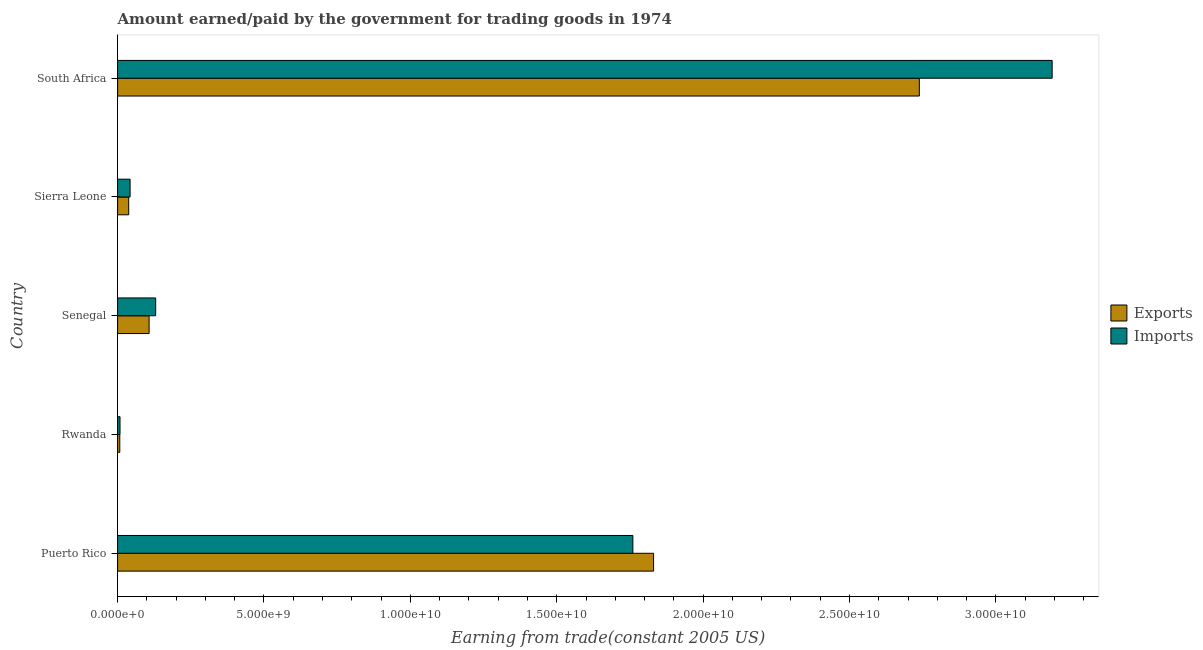Are the number of bars on each tick of the Y-axis equal?
Give a very brief answer. Yes. How many bars are there on the 5th tick from the top?
Provide a short and direct response. 2. How many bars are there on the 1st tick from the bottom?
Offer a very short reply. 2. What is the label of the 2nd group of bars from the top?
Give a very brief answer. Sierra Leone. In how many cases, is the number of bars for a given country not equal to the number of legend labels?
Give a very brief answer. 0. What is the amount paid for imports in Senegal?
Your answer should be very brief. 1.30e+09. Across all countries, what is the maximum amount earned from exports?
Ensure brevity in your answer.  2.74e+1. Across all countries, what is the minimum amount paid for imports?
Offer a very short reply. 8.25e+07. In which country was the amount earned from exports maximum?
Make the answer very short. South Africa. In which country was the amount earned from exports minimum?
Make the answer very short. Rwanda. What is the total amount paid for imports in the graph?
Offer a terse response. 5.13e+1. What is the difference between the amount paid for imports in Puerto Rico and that in Senegal?
Offer a terse response. 1.63e+1. What is the difference between the amount earned from exports in Sierra Leone and the amount paid for imports in South Africa?
Offer a terse response. -3.15e+1. What is the average amount earned from exports per country?
Your answer should be compact. 9.44e+09. What is the difference between the amount paid for imports and amount earned from exports in Rwanda?
Provide a succinct answer. 8.28e+06. What is the ratio of the amount paid for imports in Rwanda to that in Sierra Leone?
Offer a terse response. 0.19. What is the difference between the highest and the second highest amount earned from exports?
Provide a succinct answer. 9.08e+09. What is the difference between the highest and the lowest amount paid for imports?
Offer a very short reply. 3.18e+1. Is the sum of the amount paid for imports in Rwanda and Senegal greater than the maximum amount earned from exports across all countries?
Provide a succinct answer. No. What does the 1st bar from the top in Senegal represents?
Give a very brief answer. Imports. What does the 2nd bar from the bottom in Puerto Rico represents?
Provide a succinct answer. Imports. Are all the bars in the graph horizontal?
Your response must be concise. Yes. Does the graph contain any zero values?
Provide a short and direct response. No. How many legend labels are there?
Your answer should be compact. 2. What is the title of the graph?
Give a very brief answer. Amount earned/paid by the government for trading goods in 1974. What is the label or title of the X-axis?
Ensure brevity in your answer.  Earning from trade(constant 2005 US). What is the label or title of the Y-axis?
Your answer should be very brief. Country. What is the Earning from trade(constant 2005 US) in Exports in Puerto Rico?
Provide a succinct answer. 1.83e+1. What is the Earning from trade(constant 2005 US) of Imports in Puerto Rico?
Offer a terse response. 1.76e+1. What is the Earning from trade(constant 2005 US) in Exports in Rwanda?
Your response must be concise. 7.42e+07. What is the Earning from trade(constant 2005 US) in Imports in Rwanda?
Make the answer very short. 8.25e+07. What is the Earning from trade(constant 2005 US) of Exports in Senegal?
Keep it short and to the point. 1.08e+09. What is the Earning from trade(constant 2005 US) of Imports in Senegal?
Keep it short and to the point. 1.30e+09. What is the Earning from trade(constant 2005 US) in Exports in Sierra Leone?
Your answer should be compact. 3.79e+08. What is the Earning from trade(constant 2005 US) of Imports in Sierra Leone?
Offer a terse response. 4.26e+08. What is the Earning from trade(constant 2005 US) in Exports in South Africa?
Make the answer very short. 2.74e+1. What is the Earning from trade(constant 2005 US) of Imports in South Africa?
Your answer should be very brief. 3.19e+1. Across all countries, what is the maximum Earning from trade(constant 2005 US) in Exports?
Your answer should be very brief. 2.74e+1. Across all countries, what is the maximum Earning from trade(constant 2005 US) of Imports?
Ensure brevity in your answer.  3.19e+1. Across all countries, what is the minimum Earning from trade(constant 2005 US) in Exports?
Provide a succinct answer. 7.42e+07. Across all countries, what is the minimum Earning from trade(constant 2005 US) of Imports?
Offer a terse response. 8.25e+07. What is the total Earning from trade(constant 2005 US) in Exports in the graph?
Your answer should be compact. 4.72e+1. What is the total Earning from trade(constant 2005 US) in Imports in the graph?
Provide a short and direct response. 5.13e+1. What is the difference between the Earning from trade(constant 2005 US) in Exports in Puerto Rico and that in Rwanda?
Keep it short and to the point. 1.82e+1. What is the difference between the Earning from trade(constant 2005 US) in Imports in Puerto Rico and that in Rwanda?
Keep it short and to the point. 1.75e+1. What is the difference between the Earning from trade(constant 2005 US) of Exports in Puerto Rico and that in Senegal?
Keep it short and to the point. 1.72e+1. What is the difference between the Earning from trade(constant 2005 US) of Imports in Puerto Rico and that in Senegal?
Your answer should be very brief. 1.63e+1. What is the difference between the Earning from trade(constant 2005 US) of Exports in Puerto Rico and that in Sierra Leone?
Your answer should be very brief. 1.79e+1. What is the difference between the Earning from trade(constant 2005 US) of Imports in Puerto Rico and that in Sierra Leone?
Keep it short and to the point. 1.72e+1. What is the difference between the Earning from trade(constant 2005 US) in Exports in Puerto Rico and that in South Africa?
Provide a short and direct response. -9.08e+09. What is the difference between the Earning from trade(constant 2005 US) in Imports in Puerto Rico and that in South Africa?
Offer a terse response. -1.43e+1. What is the difference between the Earning from trade(constant 2005 US) in Exports in Rwanda and that in Senegal?
Provide a short and direct response. -1.00e+09. What is the difference between the Earning from trade(constant 2005 US) of Imports in Rwanda and that in Senegal?
Provide a succinct answer. -1.22e+09. What is the difference between the Earning from trade(constant 2005 US) in Exports in Rwanda and that in Sierra Leone?
Your answer should be compact. -3.05e+08. What is the difference between the Earning from trade(constant 2005 US) in Imports in Rwanda and that in Sierra Leone?
Ensure brevity in your answer.  -3.44e+08. What is the difference between the Earning from trade(constant 2005 US) in Exports in Rwanda and that in South Africa?
Your response must be concise. -2.73e+1. What is the difference between the Earning from trade(constant 2005 US) in Imports in Rwanda and that in South Africa?
Your answer should be compact. -3.18e+1. What is the difference between the Earning from trade(constant 2005 US) in Exports in Senegal and that in Sierra Leone?
Your response must be concise. 6.97e+08. What is the difference between the Earning from trade(constant 2005 US) of Imports in Senegal and that in Sierra Leone?
Ensure brevity in your answer.  8.74e+08. What is the difference between the Earning from trade(constant 2005 US) of Exports in Senegal and that in South Africa?
Provide a succinct answer. -2.63e+1. What is the difference between the Earning from trade(constant 2005 US) in Imports in Senegal and that in South Africa?
Your answer should be compact. -3.06e+1. What is the difference between the Earning from trade(constant 2005 US) of Exports in Sierra Leone and that in South Africa?
Offer a terse response. -2.70e+1. What is the difference between the Earning from trade(constant 2005 US) of Imports in Sierra Leone and that in South Africa?
Your answer should be very brief. -3.15e+1. What is the difference between the Earning from trade(constant 2005 US) in Exports in Puerto Rico and the Earning from trade(constant 2005 US) in Imports in Rwanda?
Your answer should be very brief. 1.82e+1. What is the difference between the Earning from trade(constant 2005 US) of Exports in Puerto Rico and the Earning from trade(constant 2005 US) of Imports in Senegal?
Give a very brief answer. 1.70e+1. What is the difference between the Earning from trade(constant 2005 US) in Exports in Puerto Rico and the Earning from trade(constant 2005 US) in Imports in Sierra Leone?
Your answer should be compact. 1.79e+1. What is the difference between the Earning from trade(constant 2005 US) in Exports in Puerto Rico and the Earning from trade(constant 2005 US) in Imports in South Africa?
Provide a short and direct response. -1.36e+1. What is the difference between the Earning from trade(constant 2005 US) of Exports in Rwanda and the Earning from trade(constant 2005 US) of Imports in Senegal?
Keep it short and to the point. -1.23e+09. What is the difference between the Earning from trade(constant 2005 US) in Exports in Rwanda and the Earning from trade(constant 2005 US) in Imports in Sierra Leone?
Offer a very short reply. -3.52e+08. What is the difference between the Earning from trade(constant 2005 US) in Exports in Rwanda and the Earning from trade(constant 2005 US) in Imports in South Africa?
Give a very brief answer. -3.18e+1. What is the difference between the Earning from trade(constant 2005 US) in Exports in Senegal and the Earning from trade(constant 2005 US) in Imports in Sierra Leone?
Your response must be concise. 6.49e+08. What is the difference between the Earning from trade(constant 2005 US) in Exports in Senegal and the Earning from trade(constant 2005 US) in Imports in South Africa?
Keep it short and to the point. -3.08e+1. What is the difference between the Earning from trade(constant 2005 US) in Exports in Sierra Leone and the Earning from trade(constant 2005 US) in Imports in South Africa?
Offer a very short reply. -3.15e+1. What is the average Earning from trade(constant 2005 US) of Exports per country?
Offer a terse response. 9.44e+09. What is the average Earning from trade(constant 2005 US) of Imports per country?
Your response must be concise. 1.03e+1. What is the difference between the Earning from trade(constant 2005 US) of Exports and Earning from trade(constant 2005 US) of Imports in Puerto Rico?
Provide a short and direct response. 7.07e+08. What is the difference between the Earning from trade(constant 2005 US) in Exports and Earning from trade(constant 2005 US) in Imports in Rwanda?
Keep it short and to the point. -8.28e+06. What is the difference between the Earning from trade(constant 2005 US) in Exports and Earning from trade(constant 2005 US) in Imports in Senegal?
Your answer should be compact. -2.24e+08. What is the difference between the Earning from trade(constant 2005 US) in Exports and Earning from trade(constant 2005 US) in Imports in Sierra Leone?
Make the answer very short. -4.77e+07. What is the difference between the Earning from trade(constant 2005 US) in Exports and Earning from trade(constant 2005 US) in Imports in South Africa?
Make the answer very short. -4.54e+09. What is the ratio of the Earning from trade(constant 2005 US) in Exports in Puerto Rico to that in Rwanda?
Your answer should be very brief. 246.69. What is the ratio of the Earning from trade(constant 2005 US) in Imports in Puerto Rico to that in Rwanda?
Your answer should be compact. 213.37. What is the ratio of the Earning from trade(constant 2005 US) of Exports in Puerto Rico to that in Senegal?
Your response must be concise. 17.02. What is the ratio of the Earning from trade(constant 2005 US) of Imports in Puerto Rico to that in Senegal?
Offer a terse response. 13.54. What is the ratio of the Earning from trade(constant 2005 US) in Exports in Puerto Rico to that in Sierra Leone?
Offer a terse response. 48.34. What is the ratio of the Earning from trade(constant 2005 US) of Imports in Puerto Rico to that in Sierra Leone?
Provide a succinct answer. 41.27. What is the ratio of the Earning from trade(constant 2005 US) of Exports in Puerto Rico to that in South Africa?
Provide a short and direct response. 0.67. What is the ratio of the Earning from trade(constant 2005 US) in Imports in Puerto Rico to that in South Africa?
Provide a short and direct response. 0.55. What is the ratio of the Earning from trade(constant 2005 US) in Exports in Rwanda to that in Senegal?
Your response must be concise. 0.07. What is the ratio of the Earning from trade(constant 2005 US) in Imports in Rwanda to that in Senegal?
Your answer should be compact. 0.06. What is the ratio of the Earning from trade(constant 2005 US) in Exports in Rwanda to that in Sierra Leone?
Give a very brief answer. 0.2. What is the ratio of the Earning from trade(constant 2005 US) in Imports in Rwanda to that in Sierra Leone?
Provide a succinct answer. 0.19. What is the ratio of the Earning from trade(constant 2005 US) in Exports in Rwanda to that in South Africa?
Your answer should be very brief. 0. What is the ratio of the Earning from trade(constant 2005 US) in Imports in Rwanda to that in South Africa?
Give a very brief answer. 0. What is the ratio of the Earning from trade(constant 2005 US) of Exports in Senegal to that in Sierra Leone?
Your answer should be compact. 2.84. What is the ratio of the Earning from trade(constant 2005 US) of Imports in Senegal to that in Sierra Leone?
Give a very brief answer. 3.05. What is the ratio of the Earning from trade(constant 2005 US) of Exports in Senegal to that in South Africa?
Keep it short and to the point. 0.04. What is the ratio of the Earning from trade(constant 2005 US) in Imports in Senegal to that in South Africa?
Your answer should be compact. 0.04. What is the ratio of the Earning from trade(constant 2005 US) of Exports in Sierra Leone to that in South Africa?
Provide a succinct answer. 0.01. What is the ratio of the Earning from trade(constant 2005 US) in Imports in Sierra Leone to that in South Africa?
Keep it short and to the point. 0.01. What is the difference between the highest and the second highest Earning from trade(constant 2005 US) in Exports?
Your answer should be very brief. 9.08e+09. What is the difference between the highest and the second highest Earning from trade(constant 2005 US) of Imports?
Make the answer very short. 1.43e+1. What is the difference between the highest and the lowest Earning from trade(constant 2005 US) in Exports?
Ensure brevity in your answer.  2.73e+1. What is the difference between the highest and the lowest Earning from trade(constant 2005 US) in Imports?
Keep it short and to the point. 3.18e+1. 